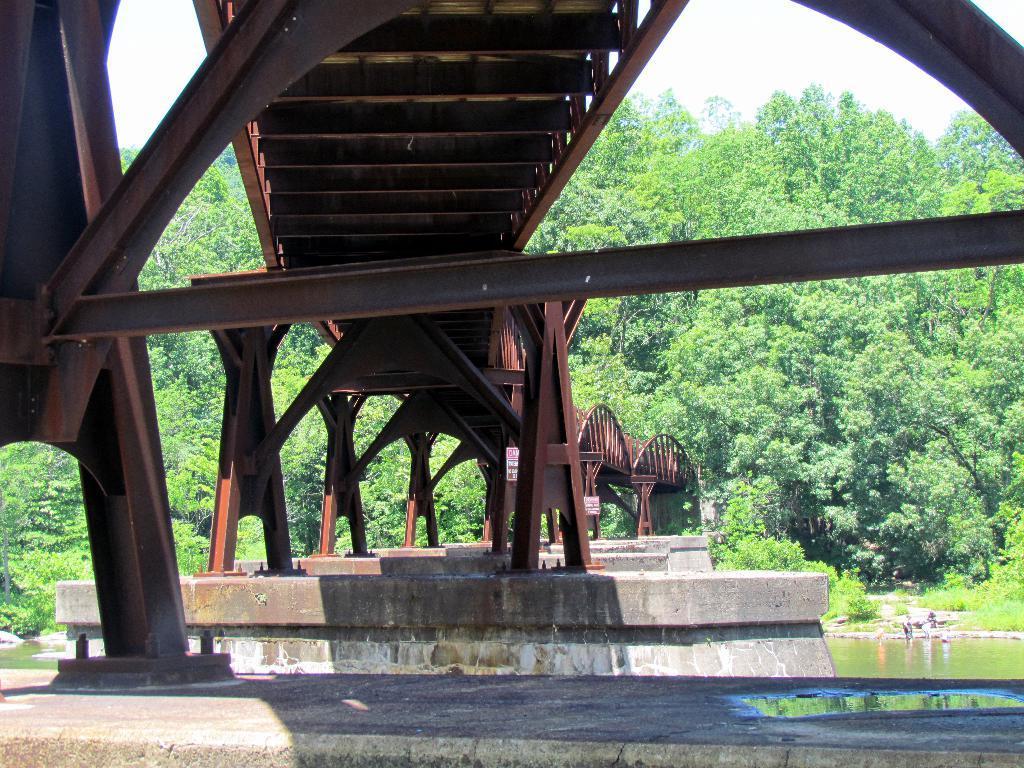Could you give a brief overview of what you see in this image? In this picture we can see a bridge over the water in the background we can see trees. 